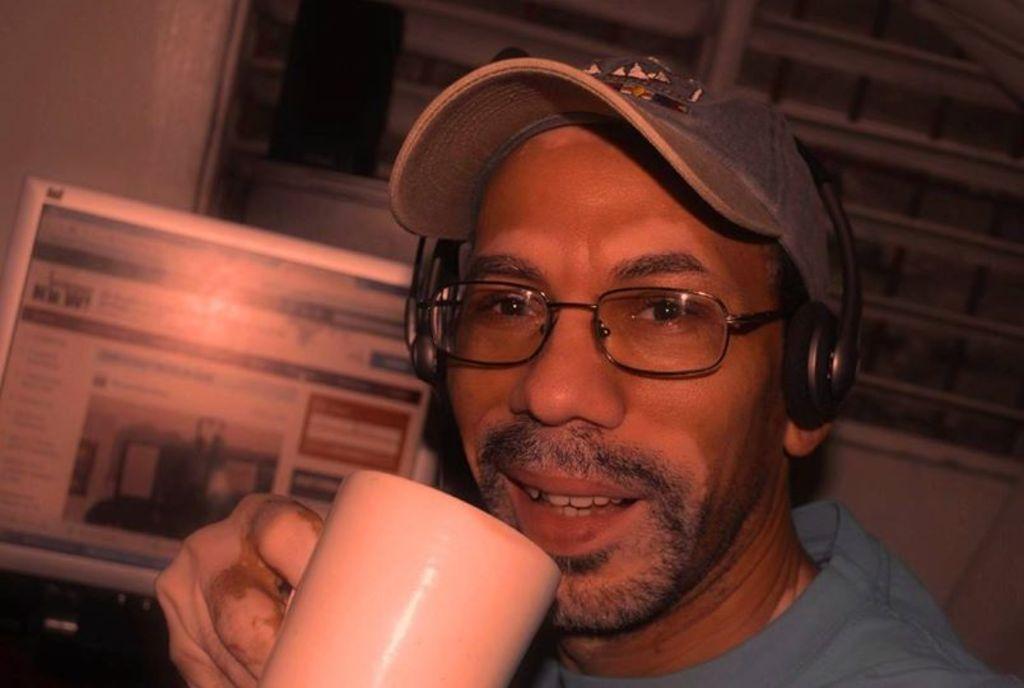Can you describe this image briefly? In this image there is a man in the middle who is wearing the cap,spectacles and headphones is holding the cup with his hand. In the background there is a computer. Behind the computer there is a window. 